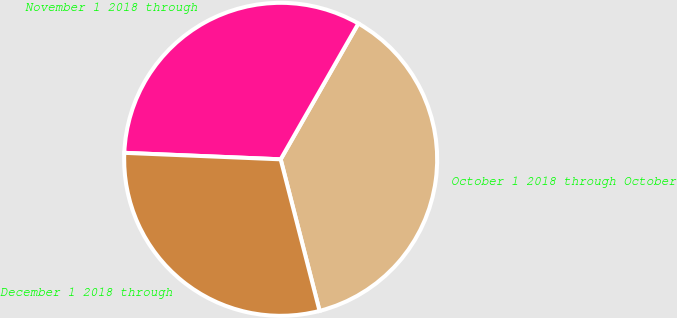Convert chart to OTSL. <chart><loc_0><loc_0><loc_500><loc_500><pie_chart><fcel>October 1 2018 through October<fcel>November 1 2018 through<fcel>December 1 2018 through<nl><fcel>37.73%<fcel>32.61%<fcel>29.66%<nl></chart> 